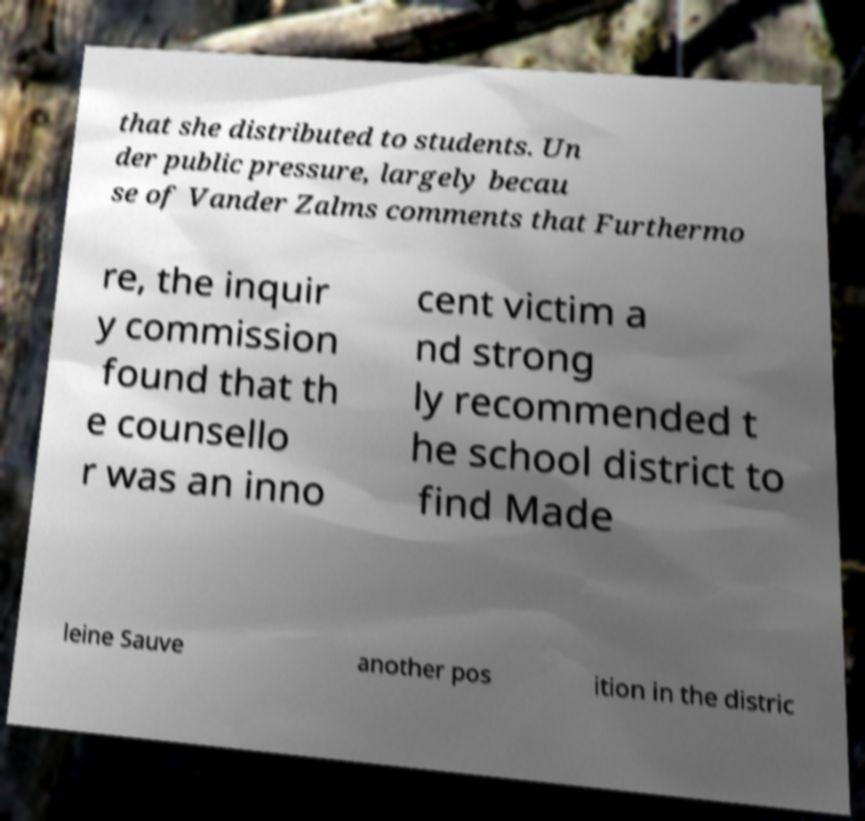Can you read and provide the text displayed in the image?This photo seems to have some interesting text. Can you extract and type it out for me? that she distributed to students. Un der public pressure, largely becau se of Vander Zalms comments that Furthermo re, the inquir y commission found that th e counsello r was an inno cent victim a nd strong ly recommended t he school district to find Made leine Sauve another pos ition in the distric 